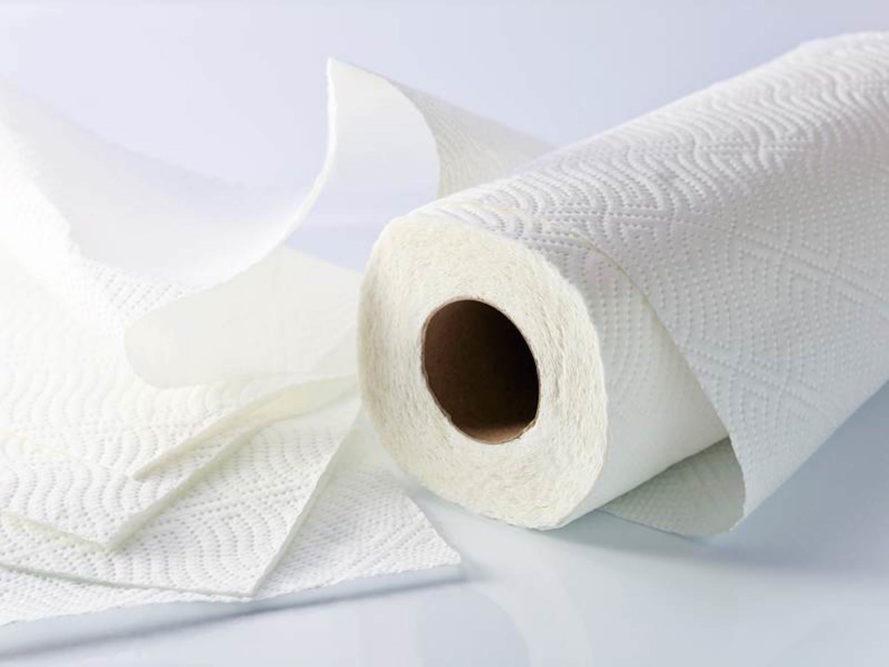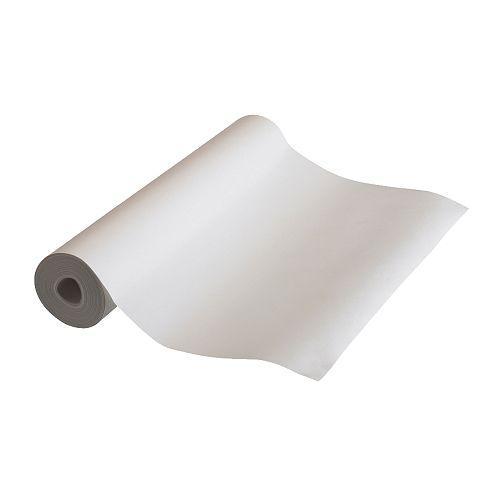The first image is the image on the left, the second image is the image on the right. For the images displayed, is the sentence "An image contains a roll of brown paper towels." factually correct? Answer yes or no. No. The first image is the image on the left, the second image is the image on the right. Given the left and right images, does the statement "An image shows one upright roll of paper towels the color of brown craft paper." hold true? Answer yes or no. No. 